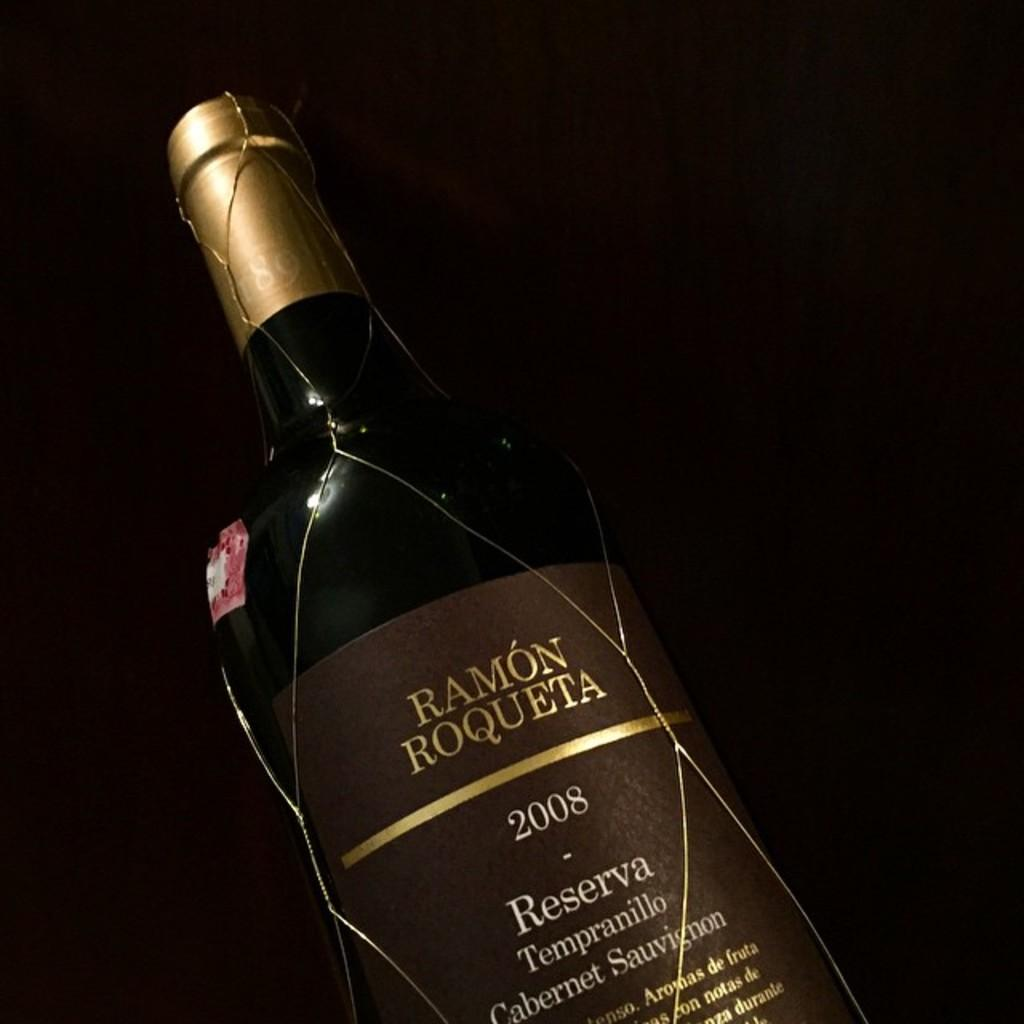<image>
Summarize the visual content of the image. An unopened bottle of Ramon Roqueta 2008 Cabernet Sauvignon, loosely wrapped in a wide fishnet. 